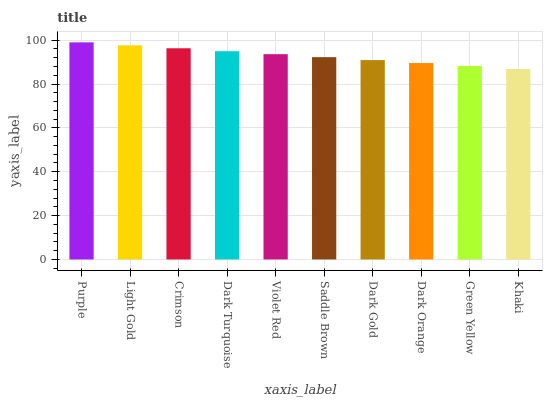Is Light Gold the minimum?
Answer yes or no. No. Is Light Gold the maximum?
Answer yes or no. No. Is Purple greater than Light Gold?
Answer yes or no. Yes. Is Light Gold less than Purple?
Answer yes or no. Yes. Is Light Gold greater than Purple?
Answer yes or no. No. Is Purple less than Light Gold?
Answer yes or no. No. Is Violet Red the high median?
Answer yes or no. Yes. Is Saddle Brown the low median?
Answer yes or no. Yes. Is Dark Orange the high median?
Answer yes or no. No. Is Green Yellow the low median?
Answer yes or no. No. 